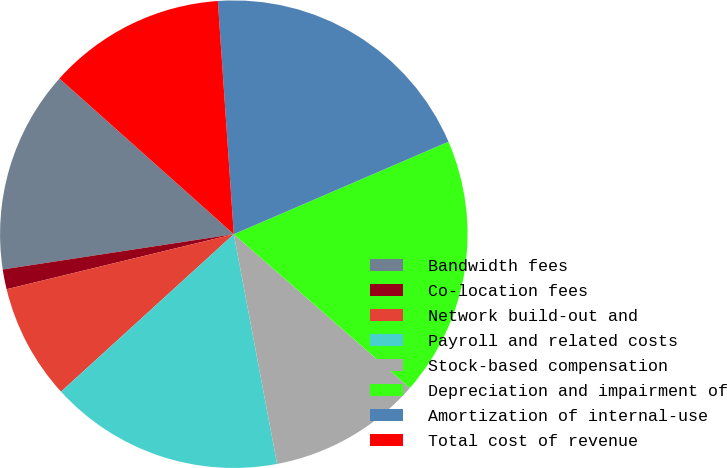Convert chart to OTSL. <chart><loc_0><loc_0><loc_500><loc_500><pie_chart><fcel>Bandwidth fees<fcel>Co-location fees<fcel>Network build-out and<fcel>Payroll and related costs<fcel>Stock-based compensation<fcel>Depreciation and impairment of<fcel>Amortization of internal-use<fcel>Total cost of revenue<nl><fcel>14.01%<fcel>1.37%<fcel>7.98%<fcel>16.2%<fcel>10.6%<fcel>17.91%<fcel>19.61%<fcel>12.31%<nl></chart> 